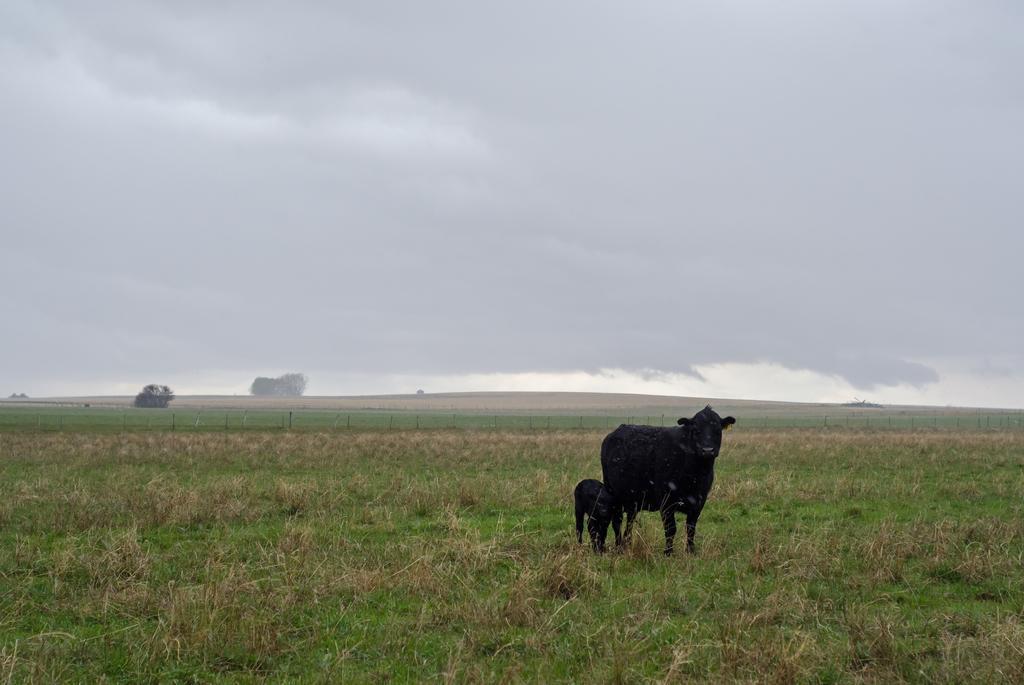Could you give a brief overview of what you see in this image? In this picture we can see two animals standing on the grass, fence, trees and in the background we can see the sky with clouds. 